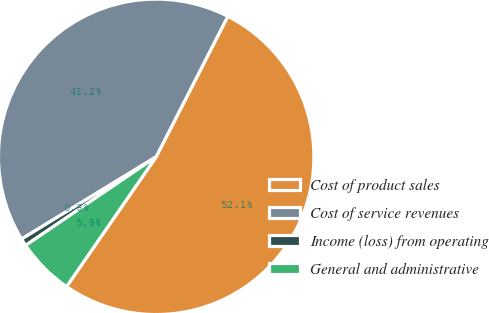<chart> <loc_0><loc_0><loc_500><loc_500><pie_chart><fcel>Cost of product sales<fcel>Cost of service revenues<fcel>Income (loss) from operating<fcel>General and administrative<nl><fcel>52.11%<fcel>41.23%<fcel>0.76%<fcel>5.89%<nl></chart> 